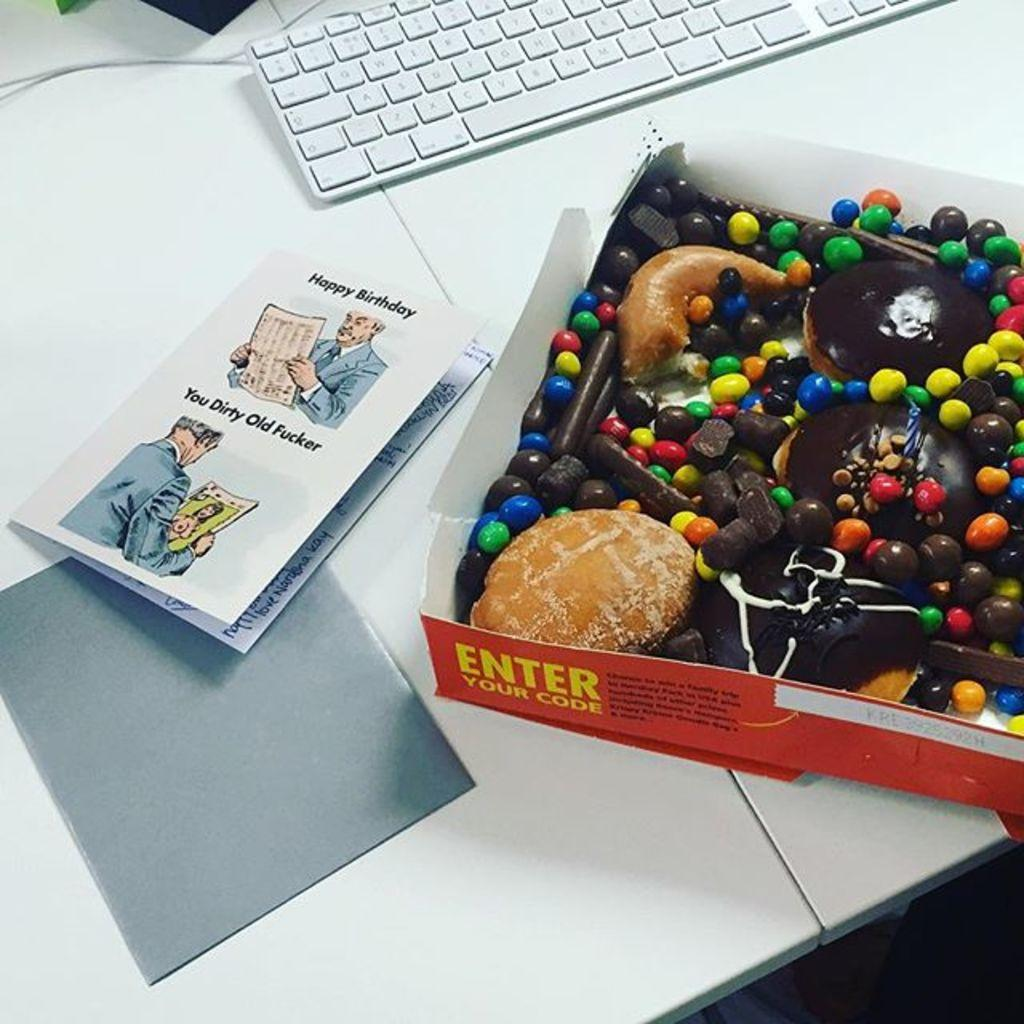Provide a one-sentence caption for the provided image. A box of doughnuts next to a card reading Happy Birthday. 